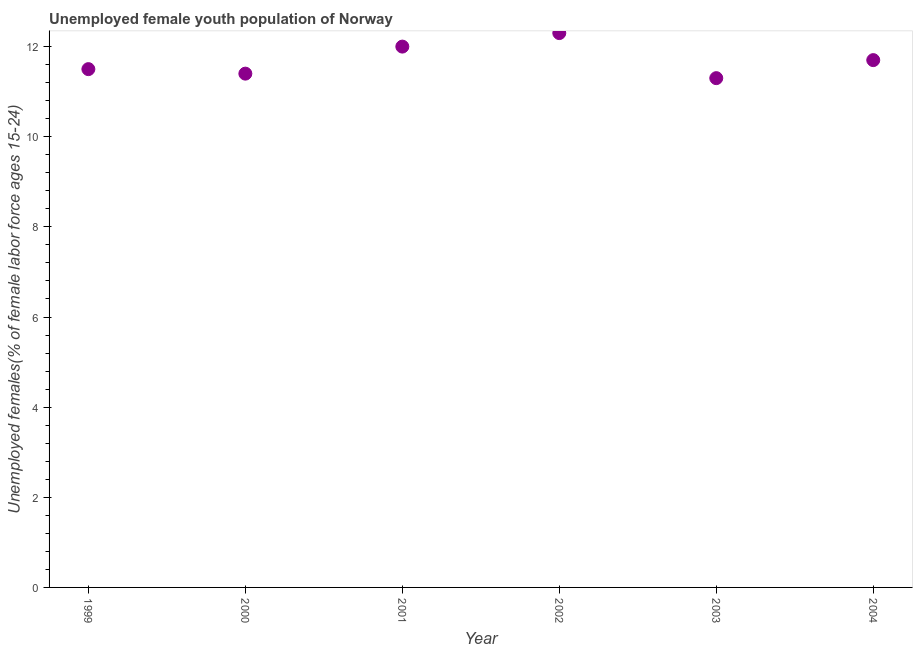What is the unemployed female youth in 2000?
Ensure brevity in your answer.  11.4. Across all years, what is the maximum unemployed female youth?
Give a very brief answer. 12.3. Across all years, what is the minimum unemployed female youth?
Offer a very short reply. 11.3. What is the sum of the unemployed female youth?
Make the answer very short. 70.2. What is the difference between the unemployed female youth in 2002 and 2004?
Your answer should be compact. 0.6. What is the average unemployed female youth per year?
Offer a very short reply. 11.7. What is the median unemployed female youth?
Ensure brevity in your answer.  11.6. Do a majority of the years between 2001 and 2000 (inclusive) have unemployed female youth greater than 3.6 %?
Ensure brevity in your answer.  No. What is the ratio of the unemployed female youth in 1999 to that in 2004?
Offer a very short reply. 0.98. What is the difference between the highest and the second highest unemployed female youth?
Keep it short and to the point. 0.3. Is the sum of the unemployed female youth in 1999 and 2002 greater than the maximum unemployed female youth across all years?
Make the answer very short. Yes. What is the difference between the highest and the lowest unemployed female youth?
Provide a succinct answer. 1. Does the graph contain any zero values?
Make the answer very short. No. What is the title of the graph?
Your response must be concise. Unemployed female youth population of Norway. What is the label or title of the Y-axis?
Make the answer very short. Unemployed females(% of female labor force ages 15-24). What is the Unemployed females(% of female labor force ages 15-24) in 1999?
Ensure brevity in your answer.  11.5. What is the Unemployed females(% of female labor force ages 15-24) in 2000?
Give a very brief answer. 11.4. What is the Unemployed females(% of female labor force ages 15-24) in 2002?
Provide a short and direct response. 12.3. What is the Unemployed females(% of female labor force ages 15-24) in 2003?
Your answer should be very brief. 11.3. What is the Unemployed females(% of female labor force ages 15-24) in 2004?
Your response must be concise. 11.7. What is the difference between the Unemployed females(% of female labor force ages 15-24) in 1999 and 2001?
Offer a terse response. -0.5. What is the difference between the Unemployed females(% of female labor force ages 15-24) in 1999 and 2002?
Your response must be concise. -0.8. What is the difference between the Unemployed females(% of female labor force ages 15-24) in 1999 and 2003?
Provide a succinct answer. 0.2. What is the difference between the Unemployed females(% of female labor force ages 15-24) in 1999 and 2004?
Make the answer very short. -0.2. What is the difference between the Unemployed females(% of female labor force ages 15-24) in 2000 and 2001?
Make the answer very short. -0.6. What is the difference between the Unemployed females(% of female labor force ages 15-24) in 2000 and 2002?
Keep it short and to the point. -0.9. What is the difference between the Unemployed females(% of female labor force ages 15-24) in 2000 and 2004?
Your answer should be compact. -0.3. What is the difference between the Unemployed females(% of female labor force ages 15-24) in 2001 and 2002?
Ensure brevity in your answer.  -0.3. What is the difference between the Unemployed females(% of female labor force ages 15-24) in 2003 and 2004?
Give a very brief answer. -0.4. What is the ratio of the Unemployed females(% of female labor force ages 15-24) in 1999 to that in 2001?
Offer a terse response. 0.96. What is the ratio of the Unemployed females(% of female labor force ages 15-24) in 1999 to that in 2002?
Make the answer very short. 0.94. What is the ratio of the Unemployed females(% of female labor force ages 15-24) in 1999 to that in 2003?
Provide a short and direct response. 1.02. What is the ratio of the Unemployed females(% of female labor force ages 15-24) in 2000 to that in 2002?
Offer a terse response. 0.93. What is the ratio of the Unemployed females(% of female labor force ages 15-24) in 2001 to that in 2002?
Your answer should be very brief. 0.98. What is the ratio of the Unemployed females(% of female labor force ages 15-24) in 2001 to that in 2003?
Make the answer very short. 1.06. What is the ratio of the Unemployed females(% of female labor force ages 15-24) in 2001 to that in 2004?
Your response must be concise. 1.03. What is the ratio of the Unemployed females(% of female labor force ages 15-24) in 2002 to that in 2003?
Ensure brevity in your answer.  1.09. What is the ratio of the Unemployed females(% of female labor force ages 15-24) in 2002 to that in 2004?
Offer a very short reply. 1.05. 